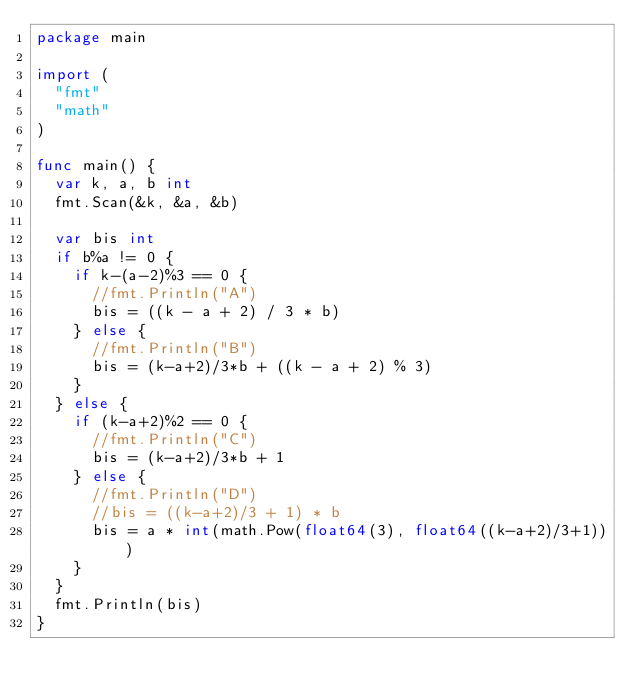<code> <loc_0><loc_0><loc_500><loc_500><_Go_>package main

import (
	"fmt"
	"math"
)

func main() {
	var k, a, b int
	fmt.Scan(&k, &a, &b)

	var bis int
	if b%a != 0 {
		if k-(a-2)%3 == 0 {
			//fmt.Println("A")
			bis = ((k - a + 2) / 3 * b)
		} else {
			//fmt.Println("B")
			bis = (k-a+2)/3*b + ((k - a + 2) % 3)
		}
	} else {
		if (k-a+2)%2 == 0 {
			//fmt.Println("C")
			bis = (k-a+2)/3*b + 1
		} else {
			//fmt.Println("D")
			//bis = ((k-a+2)/3 + 1) * b
			bis = a * int(math.Pow(float64(3), float64((k-a+2)/3+1)))
		}
	}
	fmt.Println(bis)
}</code> 